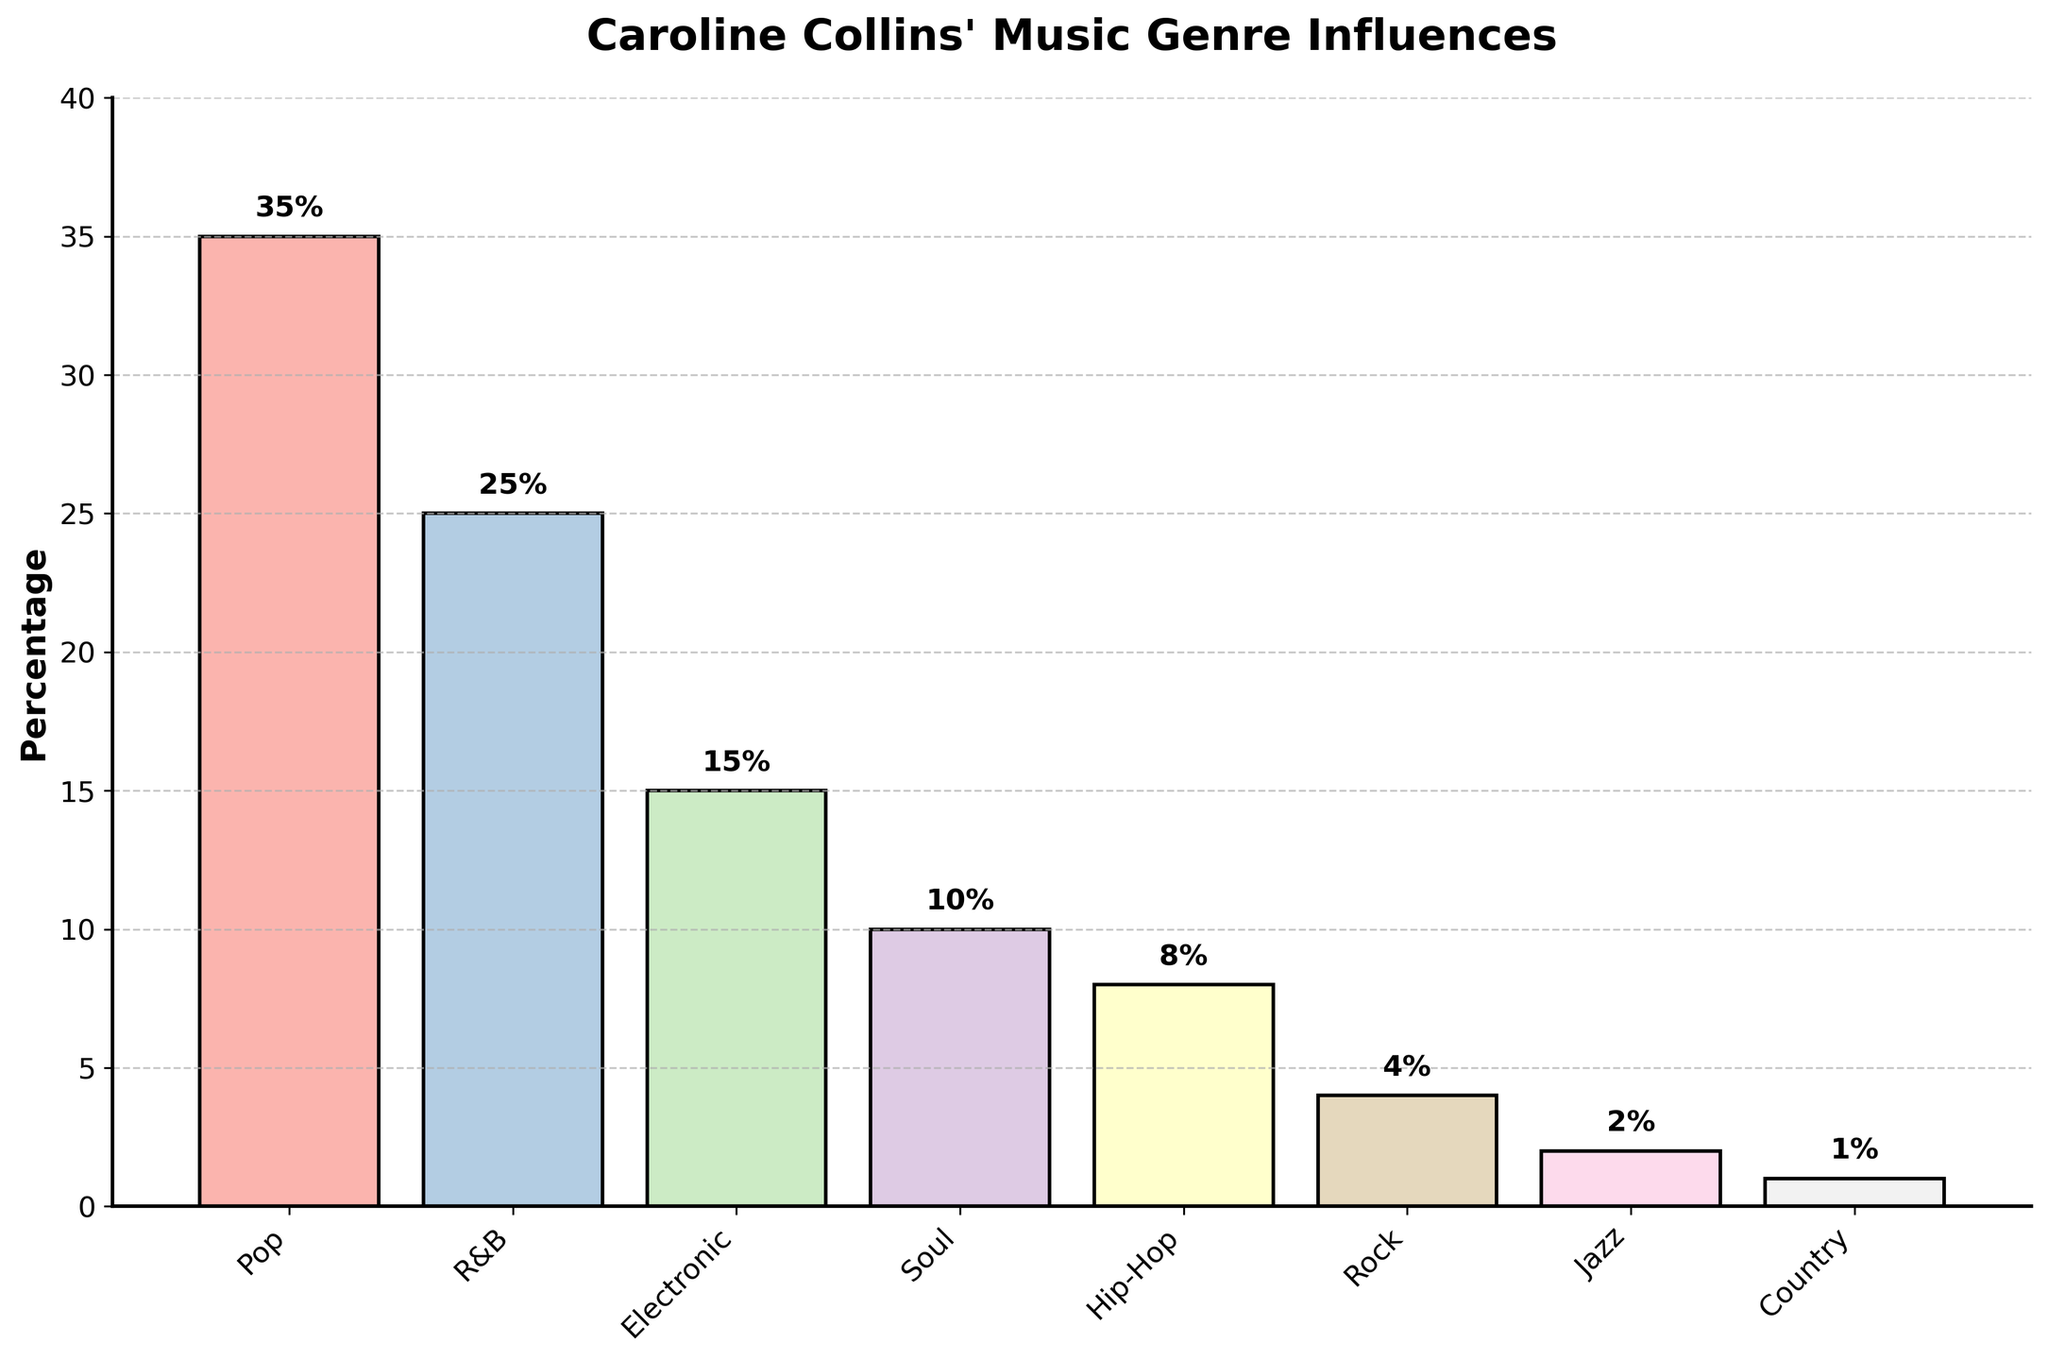Which genre has the highest percentage of influence in Caroline Collins' music? The bar chart shows the "Pop" genre bar is the tallest with a percentage label indicating 35%.
Answer: Pop What is the combined percentage of R&B and Soul influences? The R&B percentage is 25% and Soul is 10%. Adding them together gives 35%.
Answer: 35% Compare the percentage of Jazz and Rock influences. Which one is greater? The chart shows Jazz at 2% and Rock at 4%, so Rock has a higher percentage than Jazz.
Answer: Rock What is the difference in influence percentage between Electronic and Hip-Hop music? The Electronic genre is 15% and Hip-Hop is 8%. Subtracting 8% from 15% gives a difference of 7%.
Answer: 7% What visual feature distinguishes the bars in the chart? The bars are distinguished by their colors, using a gradient from the pastel color palette.
Answer: Colors What is the percentage of genres that contribute less than 5% each to Caroline Collins' music? The genres with less than 5% are Rock (4%), Jazz (2%), and Country (1%). Adding them gives 4% + 2% + 1% = 7%.
Answer: 7% Which two genres have the closest percentage values, and what are their percentages? Hip-Hop at 8% and Rock at 4% are the closest in value not having the same values but being the closest in the chart.
Answer: Hip-Hop (8%) and Rock (4%) Sum the percentages for genres influenced by Caroline Collins' music that fall below the midpoint of the chart (less than 17.5%). The genres below 17.5% are Electronic (15%), Soul (10%), Hip-Hop (8%), Rock (4%), Jazz (2%), and Country (1%). Adding these gives 15% + 10% + 8% + 4% + 2% + 1% = 40%.
Answer: 40% Find the average percentage of the top three genres influencing Caroline Collins' music. The top three genres are Pop (35%), R&B (25%), and Electronic (15%). The average is (35 + 25 + 15) / 3 = 25%.
Answer: 25% How much more influential is Soul than Country in Caroline Collins' music? Soul's percentage is 10% and Country's is 1%. Subtracting 1% from 10% gives 9%.
Answer: 9% 